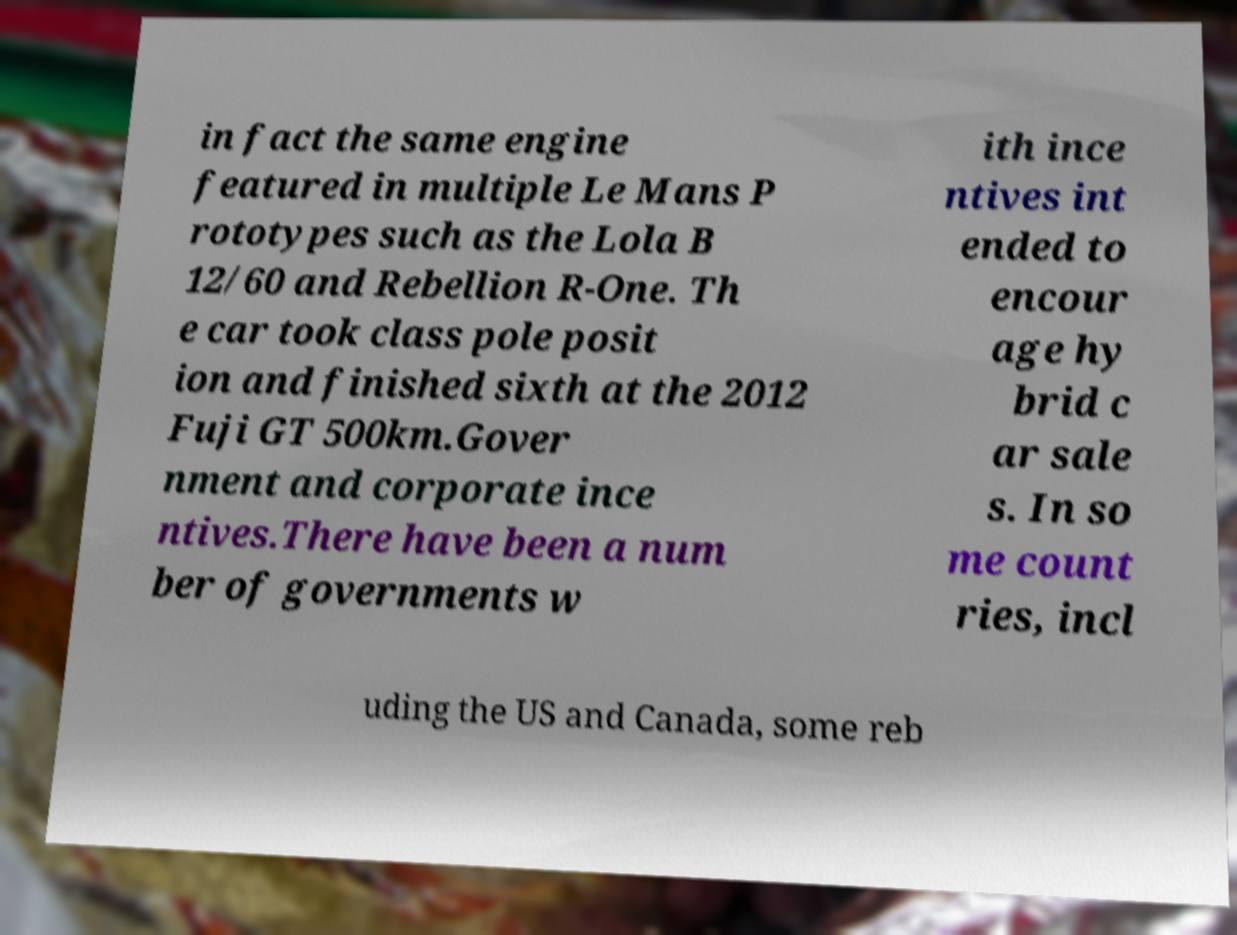Please read and relay the text visible in this image. What does it say? in fact the same engine featured in multiple Le Mans P rototypes such as the Lola B 12/60 and Rebellion R-One. Th e car took class pole posit ion and finished sixth at the 2012 Fuji GT 500km.Gover nment and corporate ince ntives.There have been a num ber of governments w ith ince ntives int ended to encour age hy brid c ar sale s. In so me count ries, incl uding the US and Canada, some reb 